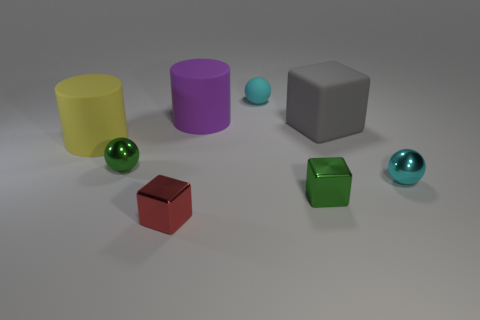Add 1 tiny green metallic balls. How many objects exist? 9 Subtract all cylinders. How many objects are left? 6 Add 7 large purple rubber objects. How many large purple rubber objects are left? 8 Add 6 cyan spheres. How many cyan spheres exist? 8 Subtract 0 cyan blocks. How many objects are left? 8 Subtract all red metal blocks. Subtract all tiny green objects. How many objects are left? 5 